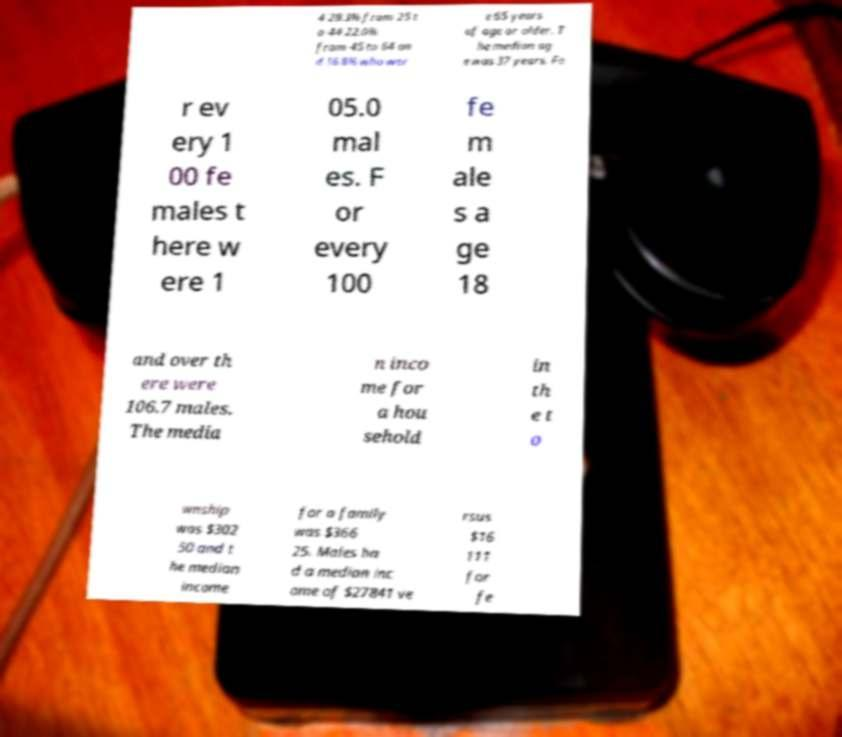Please read and relay the text visible in this image. What does it say? 4 28.3% from 25 t o 44 22.0% from 45 to 64 an d 16.8% who wer e 65 years of age or older. T he median ag e was 37 years. Fo r ev ery 1 00 fe males t here w ere 1 05.0 mal es. F or every 100 fe m ale s a ge 18 and over th ere were 106.7 males. The media n inco me for a hou sehold in th e t o wnship was $302 50 and t he median income for a family was $366 25. Males ha d a median inc ome of $27841 ve rsus $16 111 for fe 